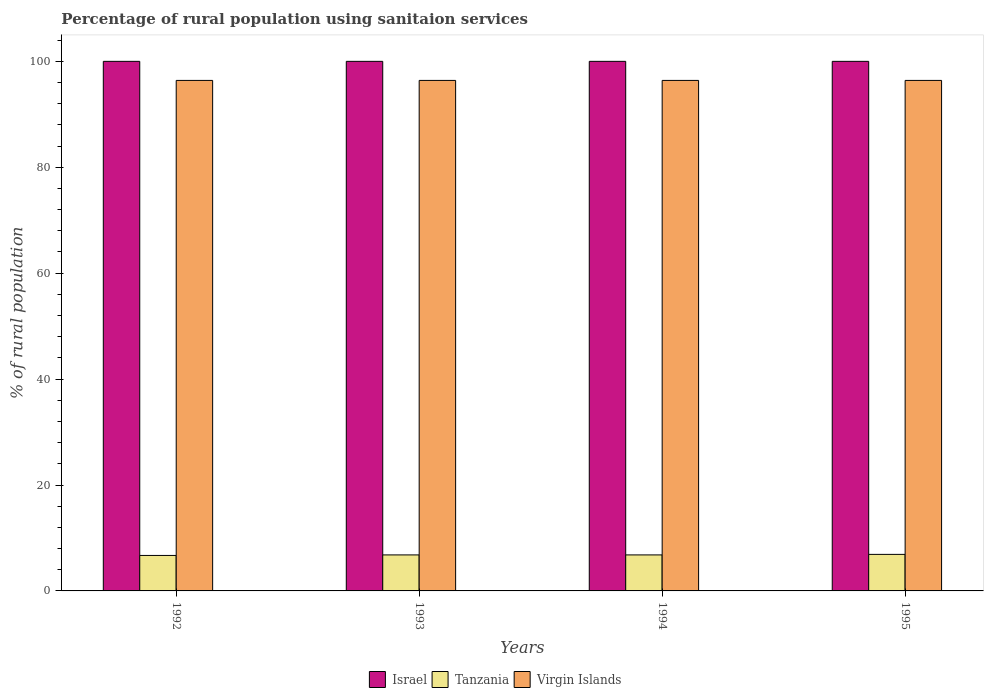How many different coloured bars are there?
Offer a terse response. 3. How many groups of bars are there?
Offer a terse response. 4. What is the percentage of rural population using sanitaion services in Tanzania in 1994?
Provide a succinct answer. 6.8. Across all years, what is the maximum percentage of rural population using sanitaion services in Israel?
Keep it short and to the point. 100. Across all years, what is the minimum percentage of rural population using sanitaion services in Virgin Islands?
Offer a terse response. 96.4. In which year was the percentage of rural population using sanitaion services in Israel minimum?
Ensure brevity in your answer.  1992. What is the total percentage of rural population using sanitaion services in Israel in the graph?
Offer a very short reply. 400. What is the difference between the percentage of rural population using sanitaion services in Tanzania in 1994 and that in 1995?
Ensure brevity in your answer.  -0.1. What is the difference between the percentage of rural population using sanitaion services in Virgin Islands in 1993 and the percentage of rural population using sanitaion services in Israel in 1994?
Make the answer very short. -3.6. What is the average percentage of rural population using sanitaion services in Tanzania per year?
Keep it short and to the point. 6.8. In the year 1994, what is the difference between the percentage of rural population using sanitaion services in Virgin Islands and percentage of rural population using sanitaion services in Israel?
Make the answer very short. -3.6. In how many years, is the percentage of rural population using sanitaion services in Tanzania greater than 92 %?
Ensure brevity in your answer.  0. What is the ratio of the percentage of rural population using sanitaion services in Israel in 1992 to that in 1994?
Ensure brevity in your answer.  1. What is the difference between the highest and the second highest percentage of rural population using sanitaion services in Tanzania?
Make the answer very short. 0.1. What is the difference between the highest and the lowest percentage of rural population using sanitaion services in Virgin Islands?
Your response must be concise. 0. What does the 2nd bar from the left in 1994 represents?
Offer a terse response. Tanzania. What does the 1st bar from the right in 1993 represents?
Offer a very short reply. Virgin Islands. How many years are there in the graph?
Your response must be concise. 4. Are the values on the major ticks of Y-axis written in scientific E-notation?
Offer a terse response. No. Does the graph contain grids?
Provide a succinct answer. No. What is the title of the graph?
Your response must be concise. Percentage of rural population using sanitaion services. Does "High income: nonOECD" appear as one of the legend labels in the graph?
Offer a terse response. No. What is the label or title of the Y-axis?
Provide a succinct answer. % of rural population. What is the % of rural population in Virgin Islands in 1992?
Provide a succinct answer. 96.4. What is the % of rural population in Israel in 1993?
Your response must be concise. 100. What is the % of rural population in Virgin Islands in 1993?
Your answer should be very brief. 96.4. What is the % of rural population in Israel in 1994?
Your answer should be compact. 100. What is the % of rural population of Virgin Islands in 1994?
Provide a succinct answer. 96.4. What is the % of rural population of Virgin Islands in 1995?
Make the answer very short. 96.4. Across all years, what is the maximum % of rural population in Virgin Islands?
Keep it short and to the point. 96.4. Across all years, what is the minimum % of rural population in Israel?
Give a very brief answer. 100. Across all years, what is the minimum % of rural population of Tanzania?
Provide a succinct answer. 6.7. Across all years, what is the minimum % of rural population in Virgin Islands?
Offer a very short reply. 96.4. What is the total % of rural population in Israel in the graph?
Ensure brevity in your answer.  400. What is the total % of rural population in Tanzania in the graph?
Keep it short and to the point. 27.2. What is the total % of rural population of Virgin Islands in the graph?
Ensure brevity in your answer.  385.6. What is the difference between the % of rural population in Israel in 1992 and that in 1993?
Your answer should be compact. 0. What is the difference between the % of rural population in Tanzania in 1992 and that in 1993?
Give a very brief answer. -0.1. What is the difference between the % of rural population in Virgin Islands in 1992 and that in 1993?
Give a very brief answer. 0. What is the difference between the % of rural population of Tanzania in 1992 and that in 1994?
Ensure brevity in your answer.  -0.1. What is the difference between the % of rural population of Virgin Islands in 1992 and that in 1994?
Offer a very short reply. 0. What is the difference between the % of rural population of Israel in 1992 and that in 1995?
Ensure brevity in your answer.  0. What is the difference between the % of rural population in Israel in 1993 and that in 1995?
Your response must be concise. 0. What is the difference between the % of rural population of Tanzania in 1993 and that in 1995?
Provide a succinct answer. -0.1. What is the difference between the % of rural population of Tanzania in 1994 and that in 1995?
Keep it short and to the point. -0.1. What is the difference between the % of rural population in Israel in 1992 and the % of rural population in Tanzania in 1993?
Give a very brief answer. 93.2. What is the difference between the % of rural population in Tanzania in 1992 and the % of rural population in Virgin Islands in 1993?
Your answer should be very brief. -89.7. What is the difference between the % of rural population in Israel in 1992 and the % of rural population in Tanzania in 1994?
Keep it short and to the point. 93.2. What is the difference between the % of rural population in Israel in 1992 and the % of rural population in Virgin Islands in 1994?
Provide a short and direct response. 3.6. What is the difference between the % of rural population in Tanzania in 1992 and the % of rural population in Virgin Islands in 1994?
Your answer should be very brief. -89.7. What is the difference between the % of rural population in Israel in 1992 and the % of rural population in Tanzania in 1995?
Ensure brevity in your answer.  93.1. What is the difference between the % of rural population in Tanzania in 1992 and the % of rural population in Virgin Islands in 1995?
Offer a terse response. -89.7. What is the difference between the % of rural population in Israel in 1993 and the % of rural population in Tanzania in 1994?
Offer a terse response. 93.2. What is the difference between the % of rural population in Tanzania in 1993 and the % of rural population in Virgin Islands in 1994?
Ensure brevity in your answer.  -89.6. What is the difference between the % of rural population in Israel in 1993 and the % of rural population in Tanzania in 1995?
Make the answer very short. 93.1. What is the difference between the % of rural population of Tanzania in 1993 and the % of rural population of Virgin Islands in 1995?
Offer a very short reply. -89.6. What is the difference between the % of rural population of Israel in 1994 and the % of rural population of Tanzania in 1995?
Make the answer very short. 93.1. What is the difference between the % of rural population of Tanzania in 1994 and the % of rural population of Virgin Islands in 1995?
Provide a short and direct response. -89.6. What is the average % of rural population in Virgin Islands per year?
Give a very brief answer. 96.4. In the year 1992, what is the difference between the % of rural population in Israel and % of rural population in Tanzania?
Give a very brief answer. 93.3. In the year 1992, what is the difference between the % of rural population in Tanzania and % of rural population in Virgin Islands?
Offer a terse response. -89.7. In the year 1993, what is the difference between the % of rural population in Israel and % of rural population in Tanzania?
Give a very brief answer. 93.2. In the year 1993, what is the difference between the % of rural population of Tanzania and % of rural population of Virgin Islands?
Offer a terse response. -89.6. In the year 1994, what is the difference between the % of rural population of Israel and % of rural population of Tanzania?
Offer a very short reply. 93.2. In the year 1994, what is the difference between the % of rural population of Israel and % of rural population of Virgin Islands?
Make the answer very short. 3.6. In the year 1994, what is the difference between the % of rural population of Tanzania and % of rural population of Virgin Islands?
Give a very brief answer. -89.6. In the year 1995, what is the difference between the % of rural population of Israel and % of rural population of Tanzania?
Provide a short and direct response. 93.1. In the year 1995, what is the difference between the % of rural population in Tanzania and % of rural population in Virgin Islands?
Ensure brevity in your answer.  -89.5. What is the ratio of the % of rural population of Israel in 1992 to that in 1993?
Provide a succinct answer. 1. What is the ratio of the % of rural population of Tanzania in 1992 to that in 1993?
Provide a short and direct response. 0.99. What is the ratio of the % of rural population of Virgin Islands in 1992 to that in 1993?
Keep it short and to the point. 1. What is the ratio of the % of rural population of Tanzania in 1992 to that in 1994?
Provide a succinct answer. 0.99. What is the ratio of the % of rural population of Israel in 1992 to that in 1995?
Offer a very short reply. 1. What is the ratio of the % of rural population in Tanzania in 1992 to that in 1995?
Your answer should be very brief. 0.97. What is the ratio of the % of rural population in Israel in 1993 to that in 1994?
Provide a succinct answer. 1. What is the ratio of the % of rural population in Tanzania in 1993 to that in 1994?
Your answer should be compact. 1. What is the ratio of the % of rural population in Tanzania in 1993 to that in 1995?
Your answer should be compact. 0.99. What is the ratio of the % of rural population in Virgin Islands in 1993 to that in 1995?
Ensure brevity in your answer.  1. What is the ratio of the % of rural population of Tanzania in 1994 to that in 1995?
Offer a terse response. 0.99. What is the ratio of the % of rural population of Virgin Islands in 1994 to that in 1995?
Your answer should be very brief. 1. What is the difference between the highest and the second highest % of rural population in Tanzania?
Offer a terse response. 0.1. What is the difference between the highest and the lowest % of rural population of Virgin Islands?
Ensure brevity in your answer.  0. 